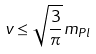Convert formula to latex. <formula><loc_0><loc_0><loc_500><loc_500>v \leq { \sqrt { \frac { 3 } { \pi } } m _ { P l } }</formula> 